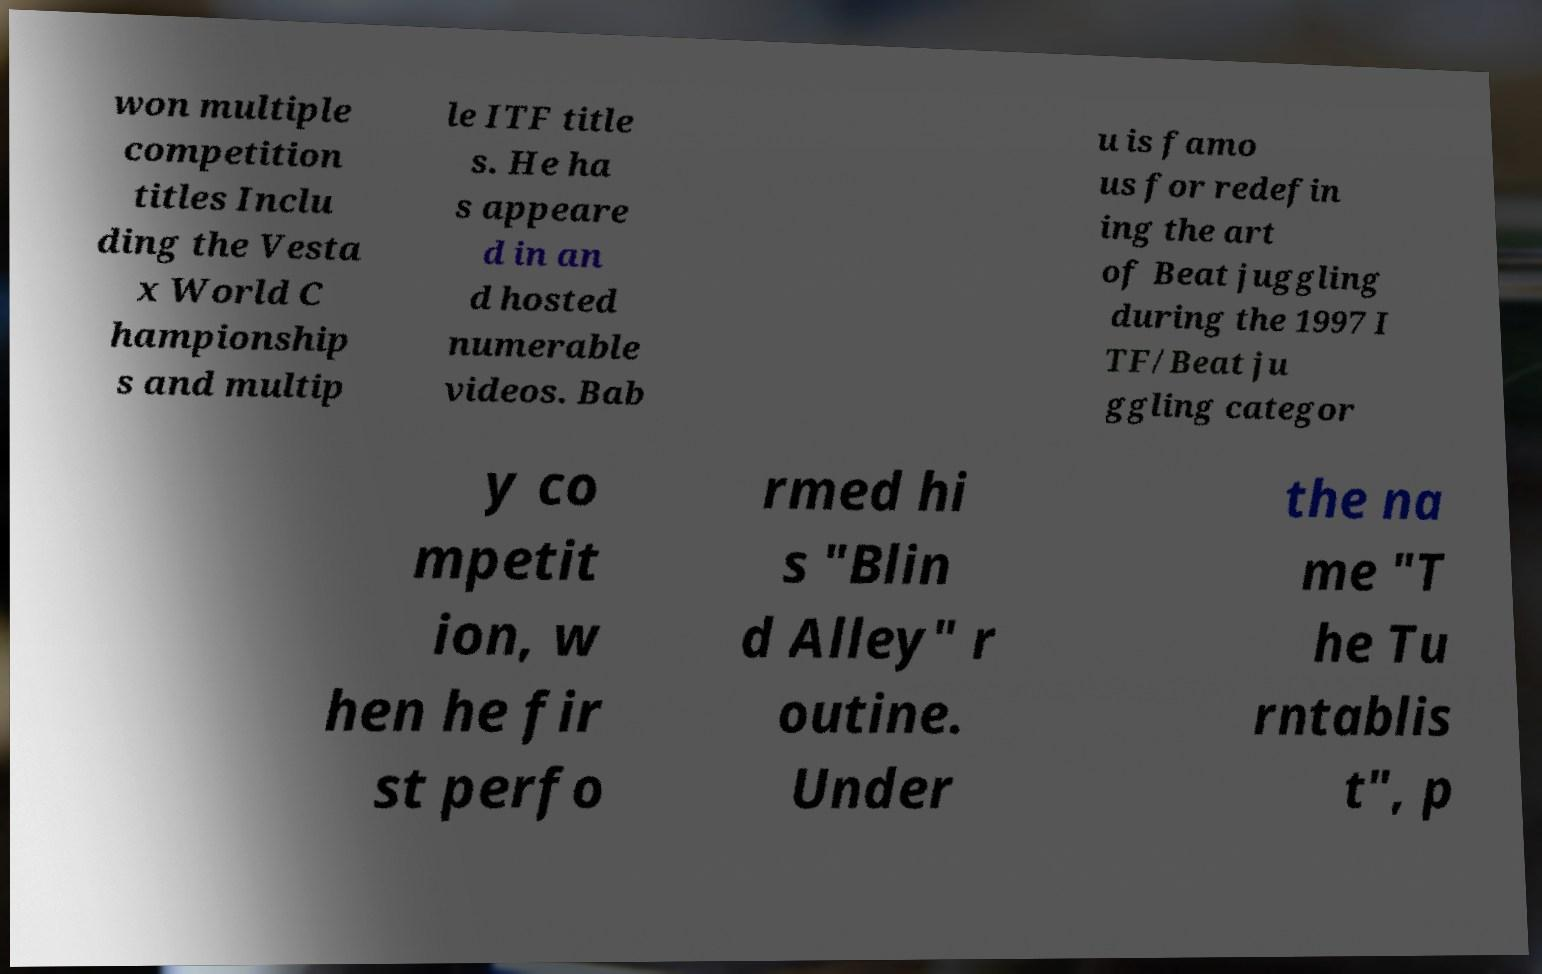There's text embedded in this image that I need extracted. Can you transcribe it verbatim? won multiple competition titles Inclu ding the Vesta x World C hampionship s and multip le ITF title s. He ha s appeare d in an d hosted numerable videos. Bab u is famo us for redefin ing the art of Beat juggling during the 1997 I TF/Beat ju ggling categor y co mpetit ion, w hen he fir st perfo rmed hi s "Blin d Alley" r outine. Under the na me "T he Tu rntablis t", p 